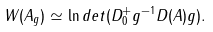<formula> <loc_0><loc_0><loc_500><loc_500>W ( A _ { g } ) \simeq \ln d e t ( D _ { 0 } ^ { + } g ^ { - 1 } D ( A ) g ) .</formula> 